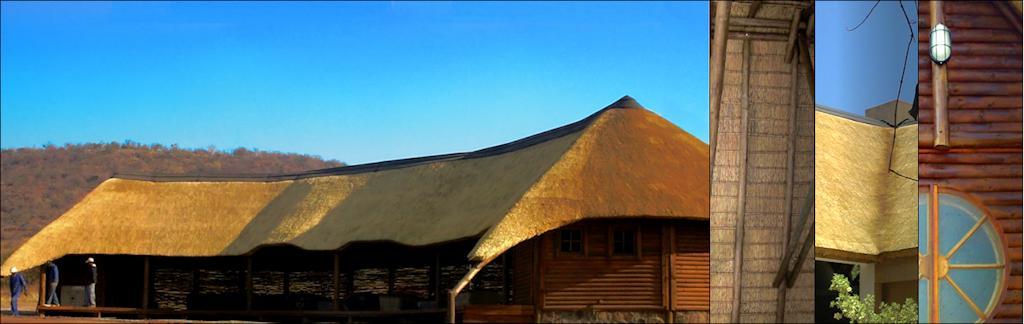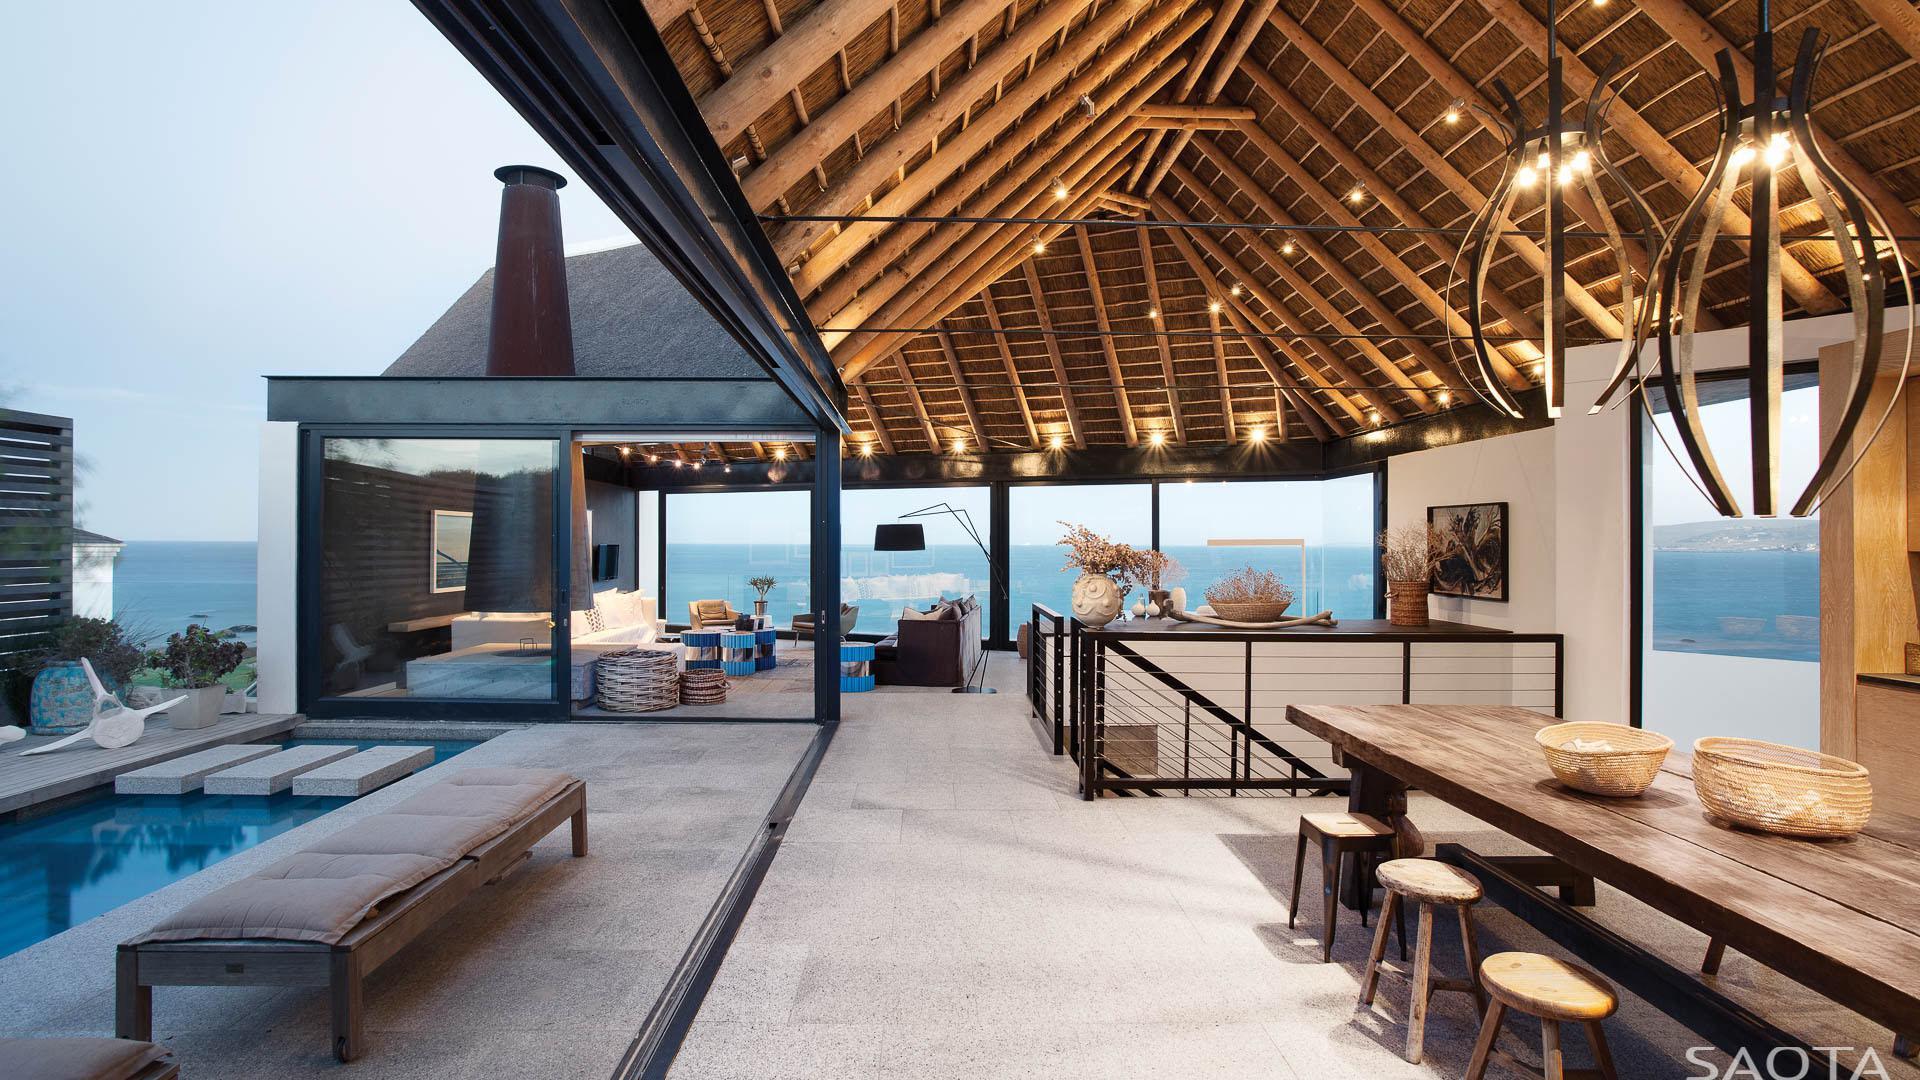The first image is the image on the left, the second image is the image on the right. Examine the images to the left and right. Is the description "One of the houses is surrounded by a green lawn; it's not merely a small green field." accurate? Answer yes or no. No. The first image is the image on the left, the second image is the image on the right. Evaluate the accuracy of this statement regarding the images: "The right image shows an exterior with a bench to the right of a narrow rectangular pool, and behind the pool large glass doors with a chimney above them in front of a dark roof.". Is it true? Answer yes or no. Yes. 